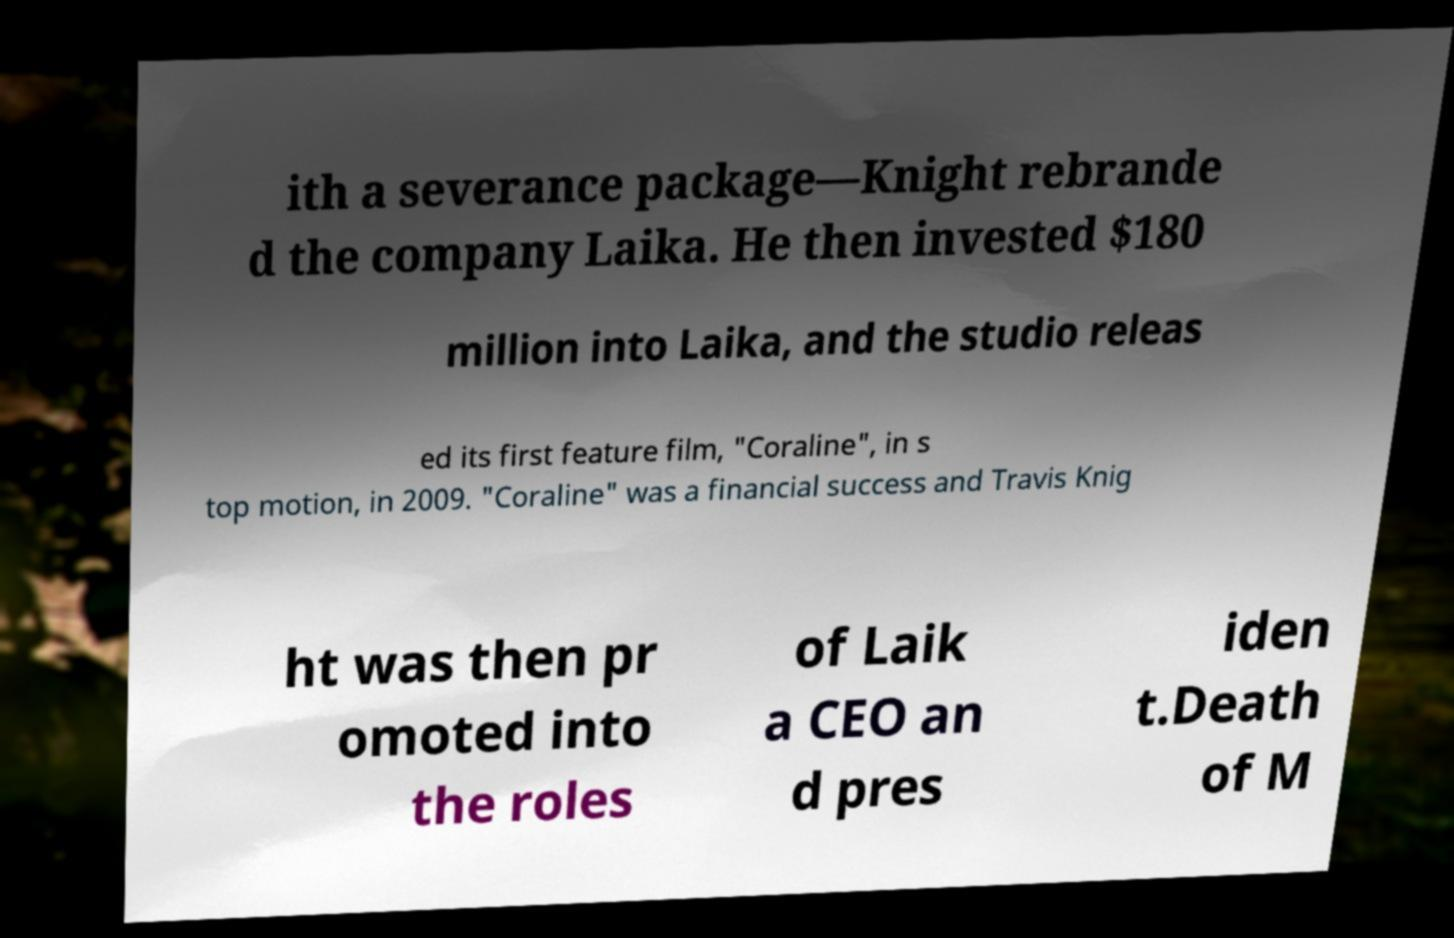For documentation purposes, I need the text within this image transcribed. Could you provide that? ith a severance package—Knight rebrande d the company Laika. He then invested $180 million into Laika, and the studio releas ed its first feature film, "Coraline", in s top motion, in 2009. "Coraline" was a financial success and Travis Knig ht was then pr omoted into the roles of Laik a CEO an d pres iden t.Death of M 